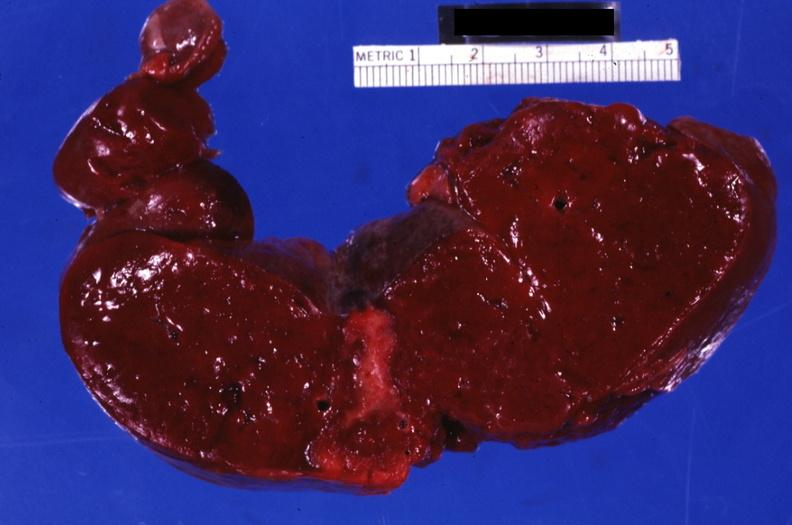does this image show section through spleen with large well shown healing infarct?
Answer the question using a single word or phrase. Yes 